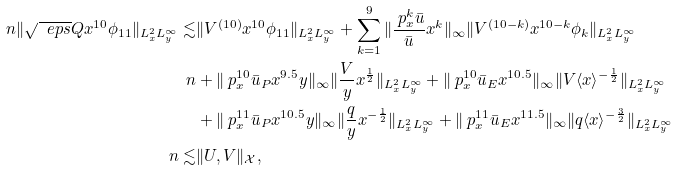<formula> <loc_0><loc_0><loc_500><loc_500>\ n \| \sqrt { \ e p s } Q x ^ { 1 0 } \phi _ { 1 1 } \| _ { L ^ { 2 } _ { x } L ^ { \infty } _ { y } } \lesssim & \| V ^ { ( 1 0 ) } x ^ { 1 0 } \phi _ { 1 1 } \| _ { L ^ { 2 } _ { x } L ^ { \infty } _ { y } } + \sum _ { k = 1 } ^ { 9 } \| \frac { \ p _ { x } ^ { k } \bar { u } } { \bar { u } } x ^ { k } \| _ { \infty } \| V ^ { ( 1 0 - k ) } x ^ { 1 0 - k } \phi _ { k } \| _ { L ^ { 2 } _ { x } L ^ { \infty } _ { y } } \\ \ n & + \| \ p _ { x } ^ { 1 0 } \bar { u } _ { P } x ^ { 9 . 5 } y \| _ { \infty } \| \frac { V } { y } x ^ { \frac { 1 } { 2 } } \| _ { L ^ { 2 } _ { x } L ^ { \infty } _ { y } } + \| \ p _ { x } ^ { 1 0 } \bar { u } _ { E } x ^ { 1 0 . 5 } \| _ { \infty } \| V \langle x \rangle ^ { - \frac { 1 } { 2 } } \| _ { L ^ { 2 } _ { x } L ^ { \infty } _ { y } } \\ & + \| \ p _ { x } ^ { 1 1 } \bar { u } _ { P } x ^ { 1 0 . 5 } y \| _ { \infty } \| \frac { q } { y } x ^ { - \frac { 1 } { 2 } } \| _ { L ^ { 2 } _ { x } L ^ { \infty } _ { y } } + \| \ p _ { x } ^ { 1 1 } \bar { u } _ { E } x ^ { 1 1 . 5 } \| _ { \infty } \| q \langle x \rangle ^ { - \frac { 3 } { 2 } } \| _ { L ^ { 2 } _ { x } L ^ { \infty } _ { y } } \\ \ n \lesssim & \| U , V \| _ { \mathcal { X } } ,</formula> 